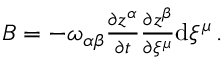Convert formula to latex. <formula><loc_0><loc_0><loc_500><loc_500>\begin{array} { r } { B = - \omega _ { \alpha \beta } \frac { \partial z ^ { \alpha } } { \partial t } \frac { \partial z ^ { \beta } } { \partial \xi ^ { \mu } } d \xi ^ { \mu } \, . } \end{array}</formula> 